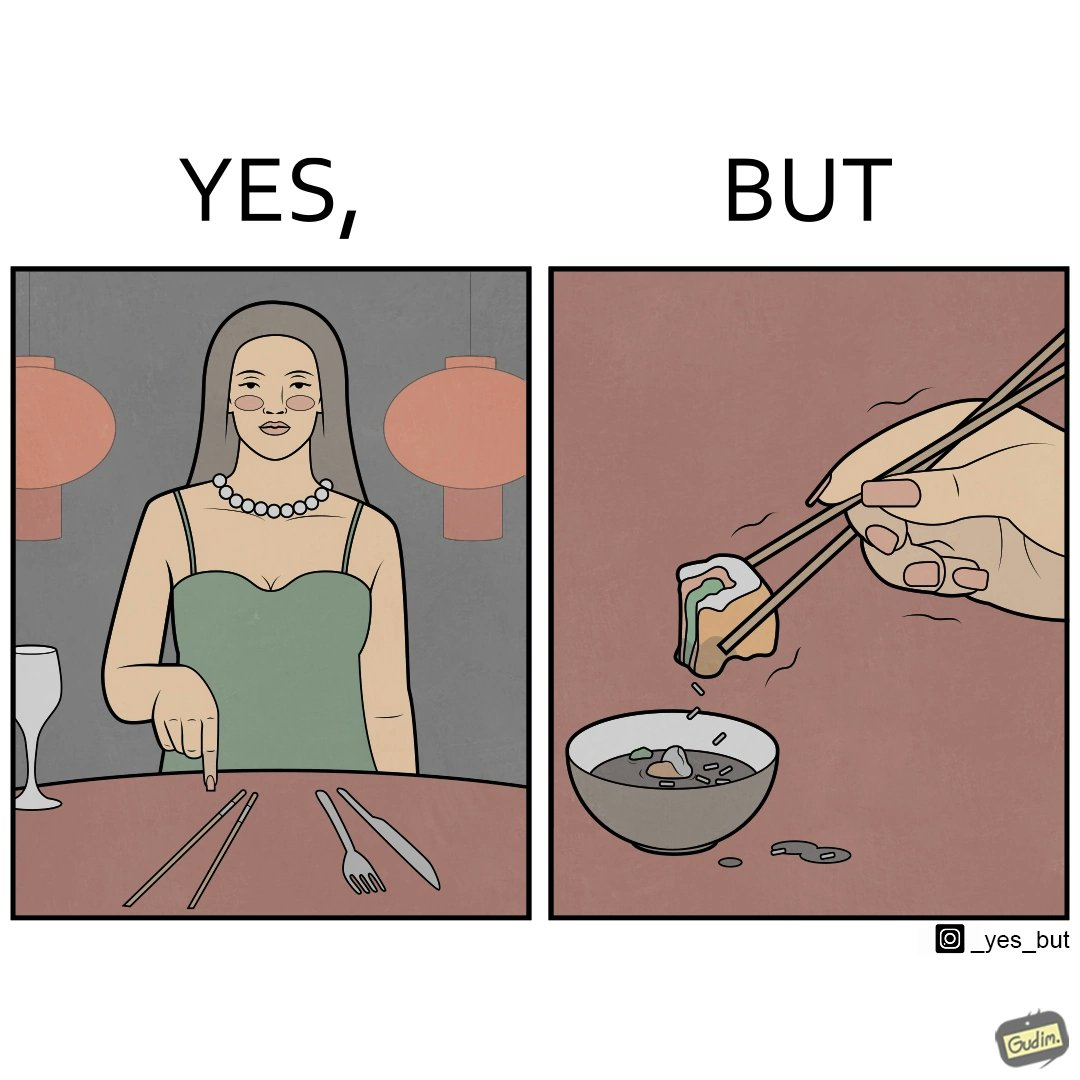Is this image satirical or non-satirical? Yes, this image is satirical. 